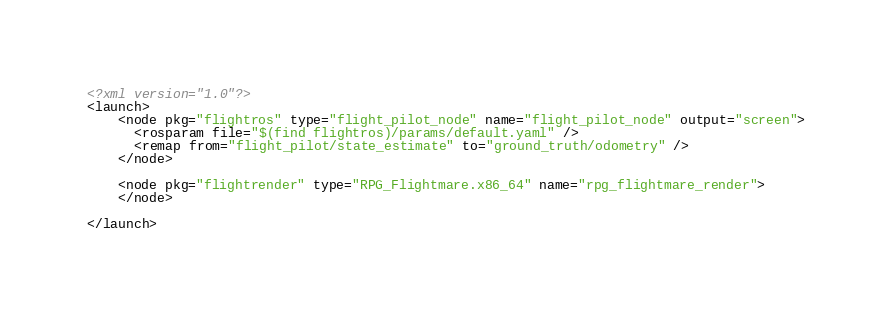Convert code to text. <code><loc_0><loc_0><loc_500><loc_500><_XML_><?xml version="1.0"?>
<launch>
    <node pkg="flightros" type="flight_pilot_node" name="flight_pilot_node" output="screen">
      <rosparam file="$(find flightros)/params/default.yaml" /> 
      <remap from="flight_pilot/state_estimate" to="ground_truth/odometry" />
    </node>

    <node pkg="flightrender" type="RPG_Flightmare.x86_64" name="rpg_flightmare_render">
    </node>

</launch></code> 